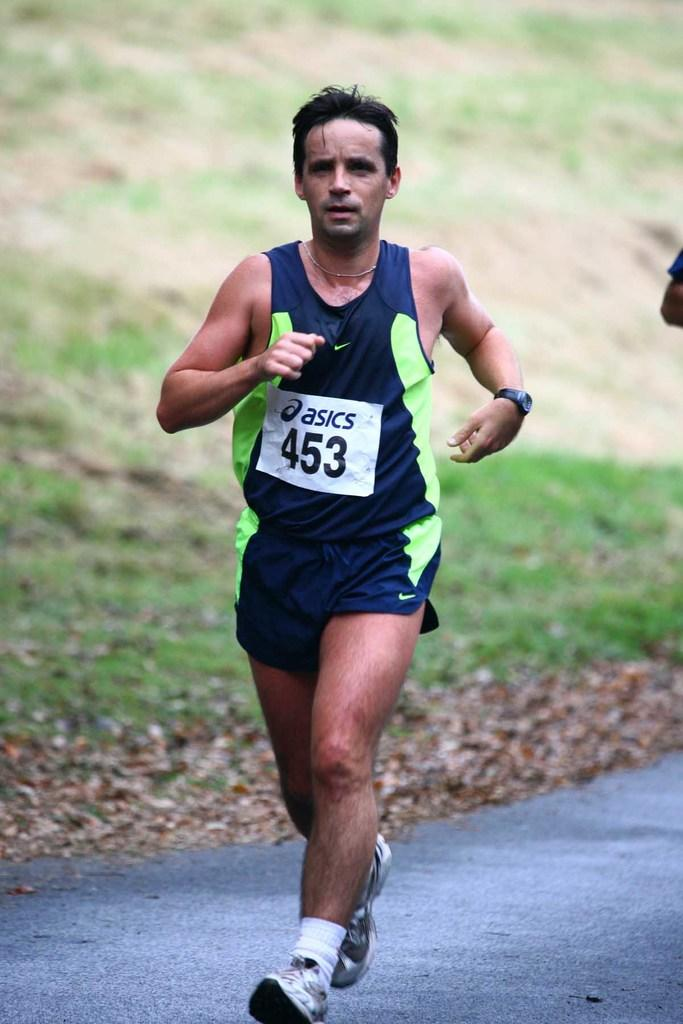Provide a one-sentence caption for the provided image. The athlete is wearing a number 453 tag. 